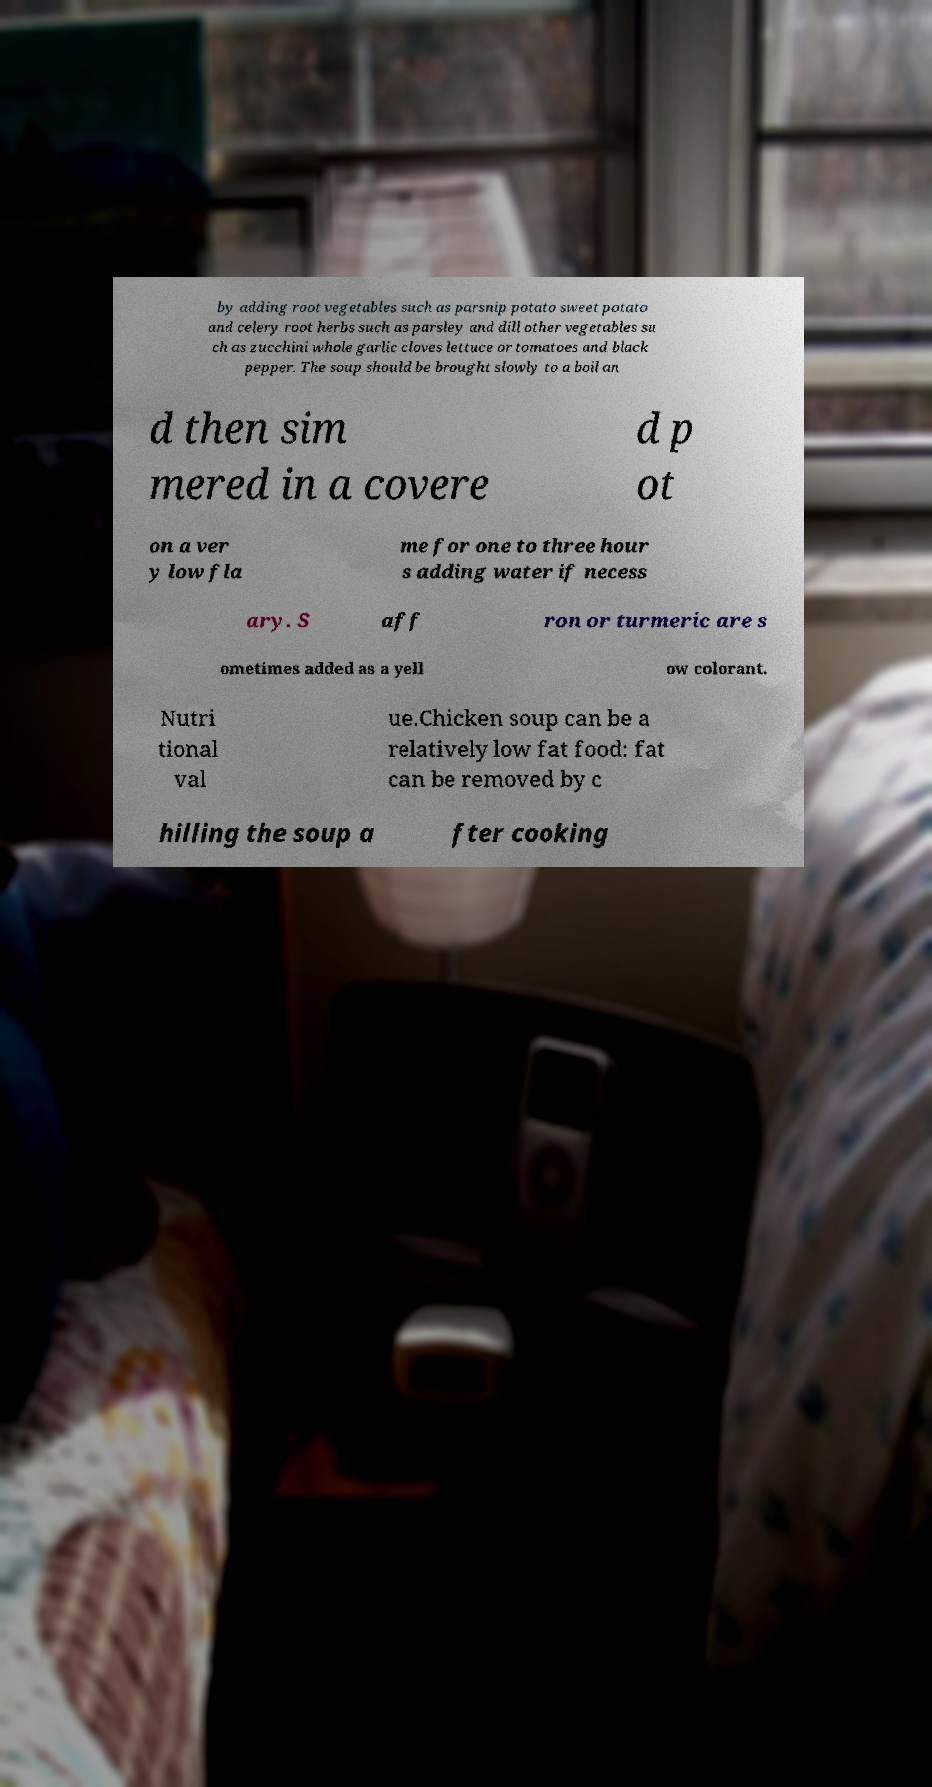Could you assist in decoding the text presented in this image and type it out clearly? by adding root vegetables such as parsnip potato sweet potato and celery root herbs such as parsley and dill other vegetables su ch as zucchini whole garlic cloves lettuce or tomatoes and black pepper. The soup should be brought slowly to a boil an d then sim mered in a covere d p ot on a ver y low fla me for one to three hour s adding water if necess ary. S aff ron or turmeric are s ometimes added as a yell ow colorant. Nutri tional val ue.Chicken soup can be a relatively low fat food: fat can be removed by c hilling the soup a fter cooking 